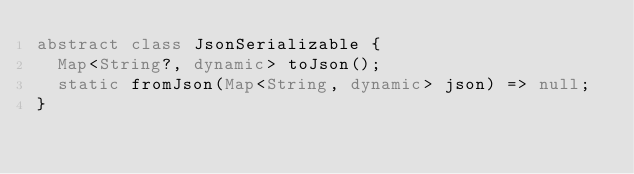<code> <loc_0><loc_0><loc_500><loc_500><_Dart_>abstract class JsonSerializable {
  Map<String?, dynamic> toJson();
  static fromJson(Map<String, dynamic> json) => null;
}
</code> 